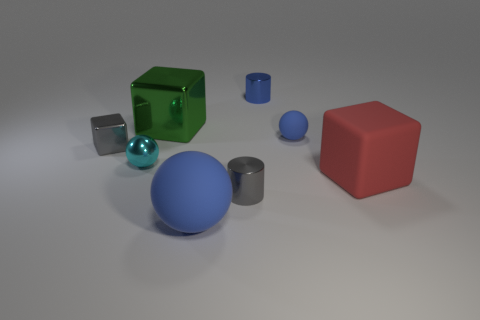There is a shiny object that is the same color as the large sphere; what is its size?
Ensure brevity in your answer.  Small. What number of other things are there of the same color as the tiny matte ball?
Provide a short and direct response. 2. Is the number of small blocks that are in front of the small block less than the number of big matte balls?
Your answer should be very brief. Yes. Is there a green rubber block that has the same size as the red rubber block?
Make the answer very short. No. There is a big rubber sphere; is its color the same as the object behind the large metallic block?
Your answer should be very brief. Yes. There is a gray thing behind the small gray cylinder; what number of large blue things are right of it?
Offer a terse response. 1. There is a sphere left of the blue matte ball in front of the big red rubber object; what color is it?
Make the answer very short. Cyan. The blue thing that is both in front of the small blue metallic cylinder and right of the small gray cylinder is made of what material?
Make the answer very short. Rubber. Is there a small cyan metallic thing that has the same shape as the large shiny thing?
Offer a very short reply. No. Does the tiny gray thing to the left of the gray cylinder have the same shape as the big red rubber thing?
Offer a very short reply. Yes. 